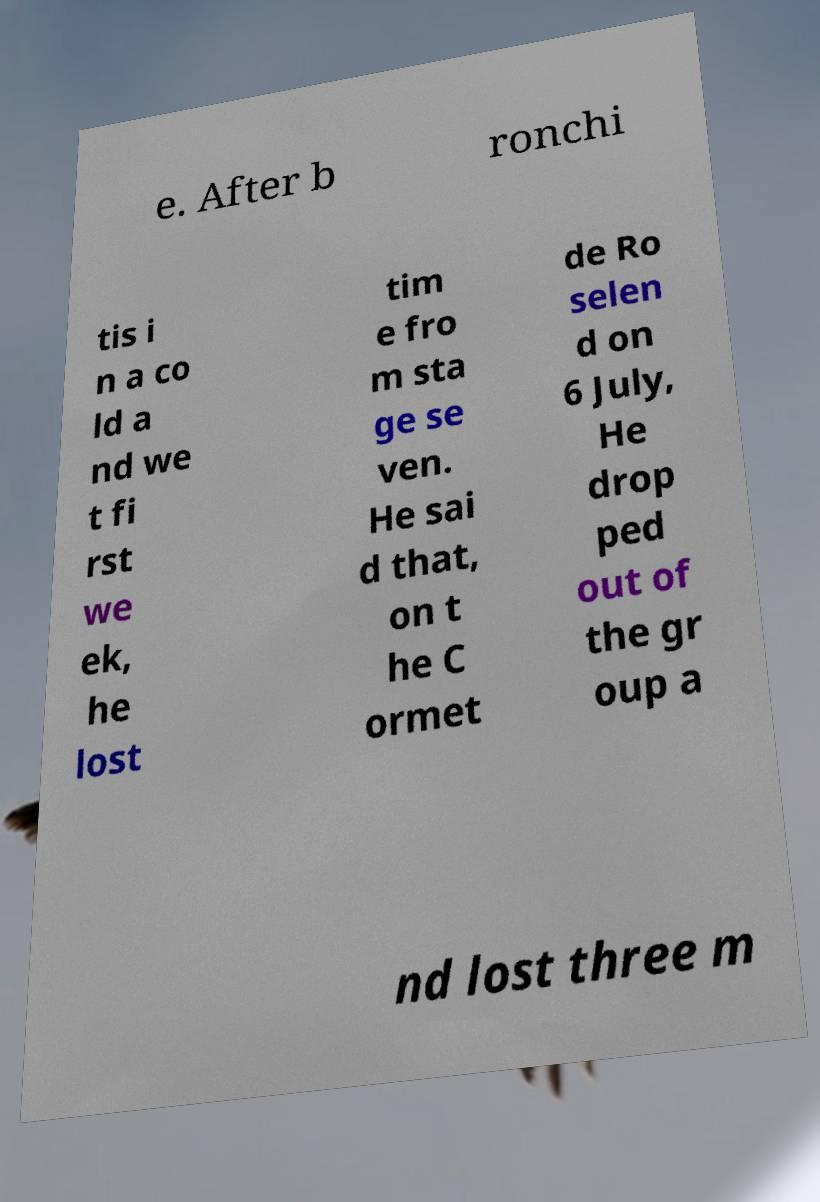What messages or text are displayed in this image? I need them in a readable, typed format. e. After b ronchi tis i n a co ld a nd we t fi rst we ek, he lost tim e fro m sta ge se ven. He sai d that, on t he C ormet de Ro selen d on 6 July, He drop ped out of the gr oup a nd lost three m 